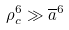Convert formula to latex. <formula><loc_0><loc_0><loc_500><loc_500>\rho _ { c } ^ { 6 } \gg \overline { a } ^ { 6 }</formula> 